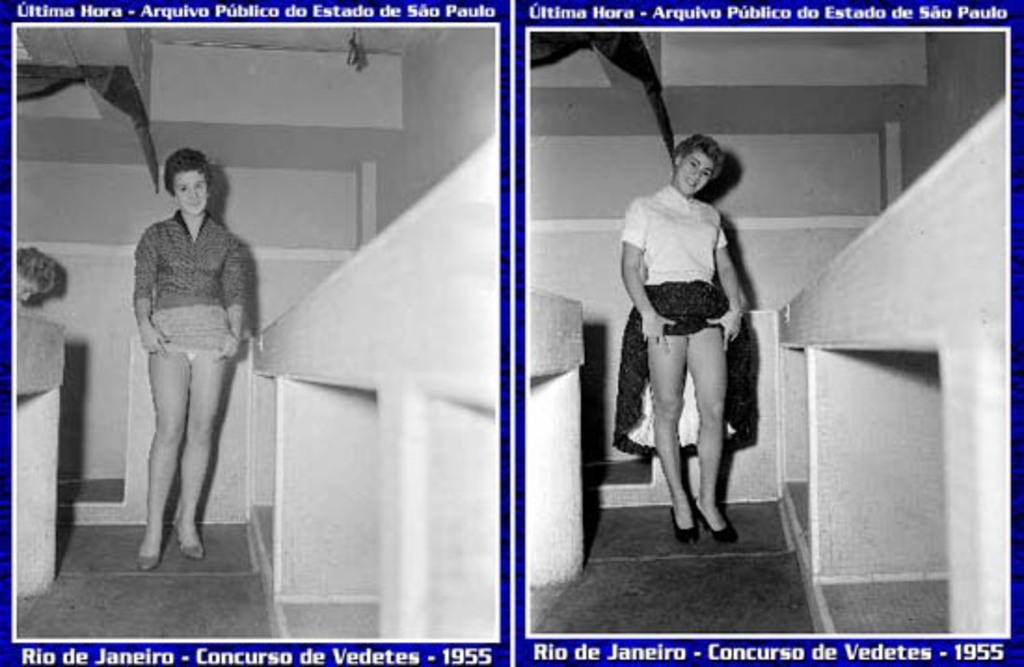Please provide a concise description of this image. This is a collage image. In this college image we can see women standing on the floor. At the top and bottom of the collage image there is some text. 